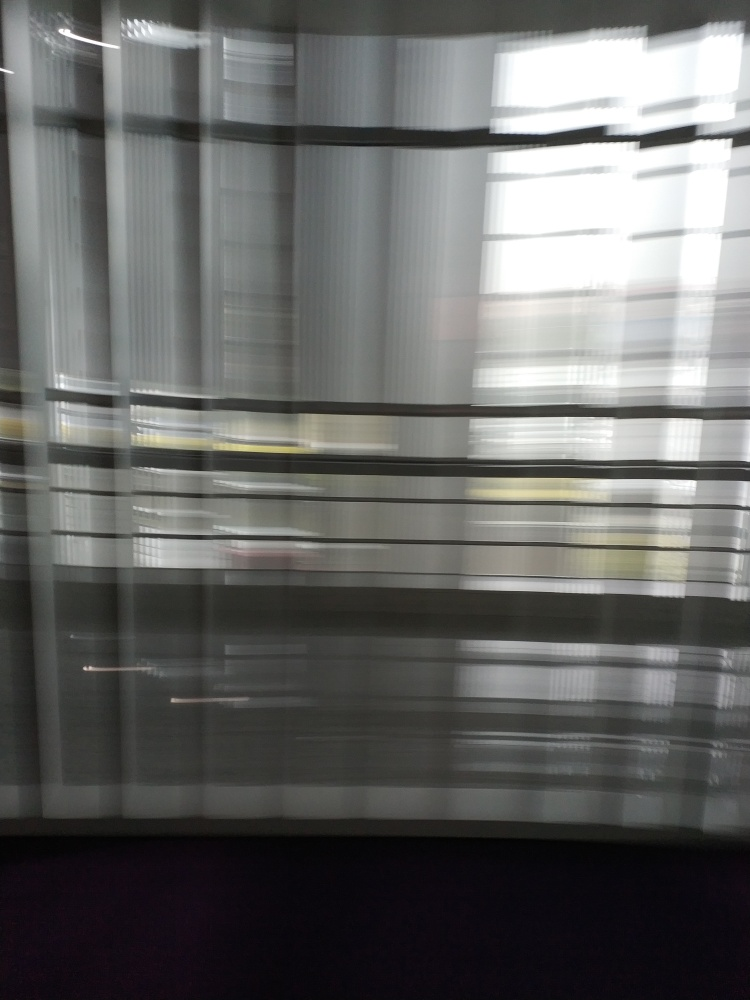Can you tell what kind of environment is behind the blinds? Due to the motion blur, it's challenging to discern specific details, but it seems like there's natural light coming through, suggesting a daytime setting possibly in an urban or office environment. What mood does this photo evoke? The blurred lines give the image a sense of speed and disorientation, which can evoke a mood of chaos or haste. Conversely, the soft overlapping patterns could also provide a sense of calm similar to looking at gentle waves or clouds. 